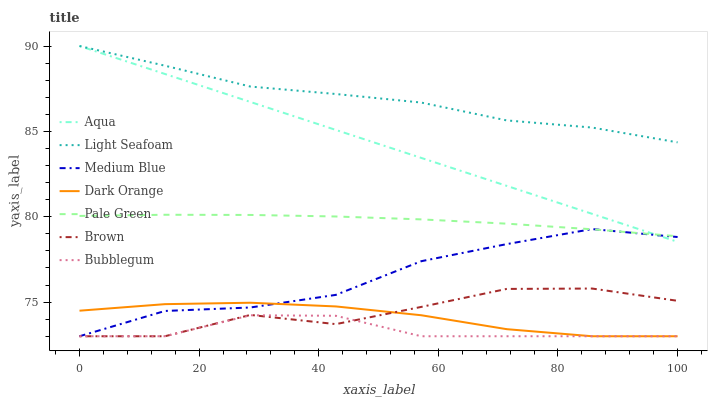Does Bubblegum have the minimum area under the curve?
Answer yes or no. Yes. Does Light Seafoam have the maximum area under the curve?
Answer yes or no. Yes. Does Dark Orange have the minimum area under the curve?
Answer yes or no. No. Does Dark Orange have the maximum area under the curve?
Answer yes or no. No. Is Aqua the smoothest?
Answer yes or no. Yes. Is Brown the roughest?
Answer yes or no. Yes. Is Dark Orange the smoothest?
Answer yes or no. No. Is Dark Orange the roughest?
Answer yes or no. No. Does Brown have the lowest value?
Answer yes or no. Yes. Does Aqua have the lowest value?
Answer yes or no. No. Does Light Seafoam have the highest value?
Answer yes or no. Yes. Does Dark Orange have the highest value?
Answer yes or no. No. Is Brown less than Pale Green?
Answer yes or no. Yes. Is Pale Green greater than Dark Orange?
Answer yes or no. Yes. Does Bubblegum intersect Brown?
Answer yes or no. Yes. Is Bubblegum less than Brown?
Answer yes or no. No. Is Bubblegum greater than Brown?
Answer yes or no. No. Does Brown intersect Pale Green?
Answer yes or no. No. 